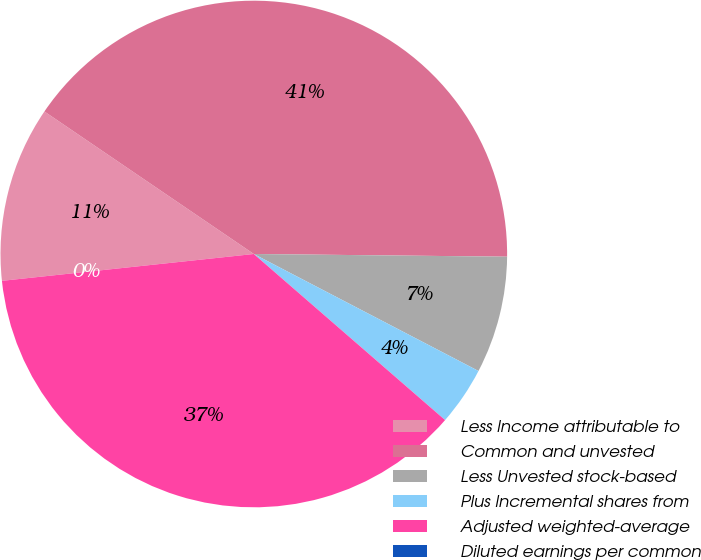<chart> <loc_0><loc_0><loc_500><loc_500><pie_chart><fcel>Less Income attributable to<fcel>Common and unvested<fcel>Less Unvested stock-based<fcel>Plus Incremental shares from<fcel>Adjusted weighted-average<fcel>Diluted earnings per common<nl><fcel>11.2%<fcel>40.66%<fcel>7.47%<fcel>3.74%<fcel>36.93%<fcel>0.0%<nl></chart> 